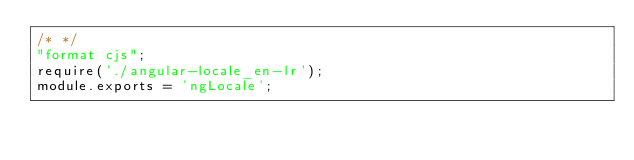Convert code to text. <code><loc_0><loc_0><loc_500><loc_500><_JavaScript_>/* */ 
"format cjs";
require('./angular-locale_en-lr');
module.exports = 'ngLocale';
</code> 